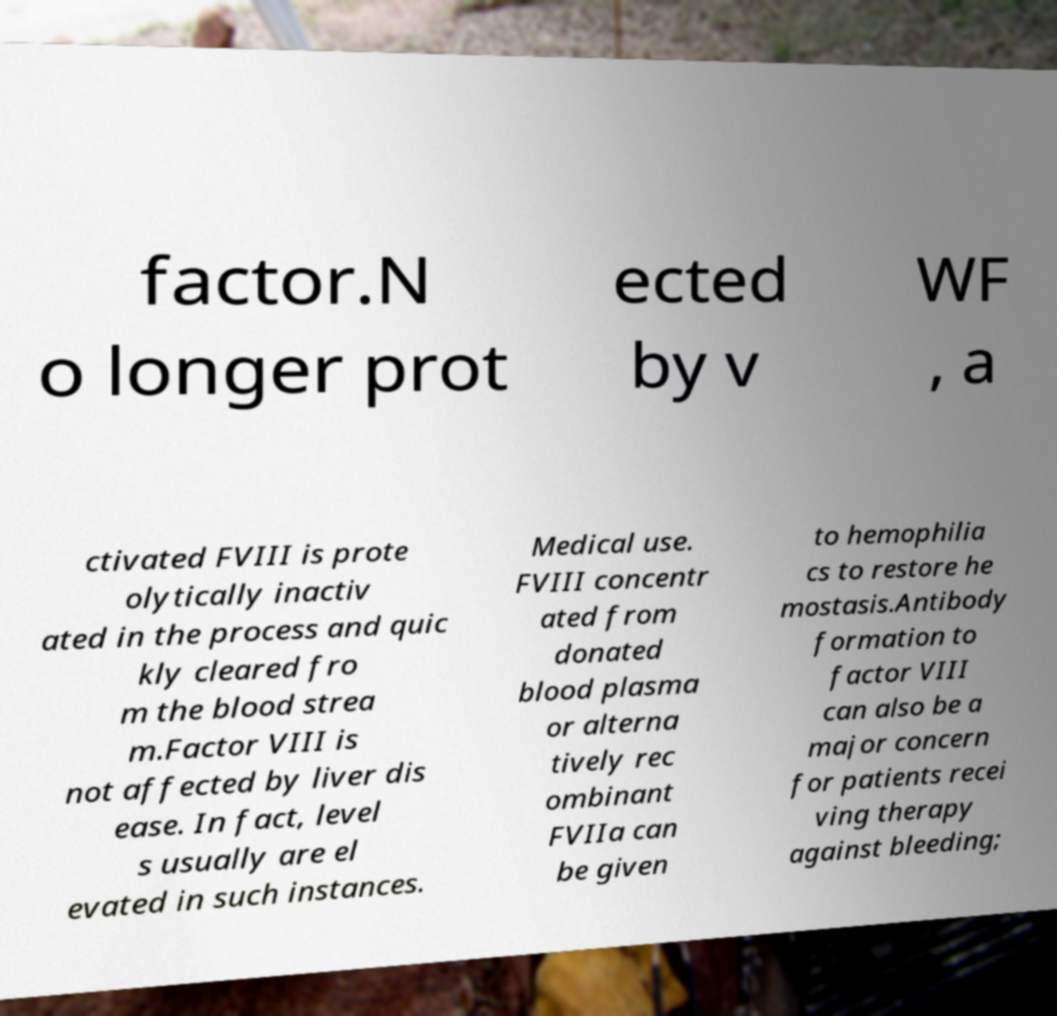Could you assist in decoding the text presented in this image and type it out clearly? factor.N o longer prot ected by v WF , a ctivated FVIII is prote olytically inactiv ated in the process and quic kly cleared fro m the blood strea m.Factor VIII is not affected by liver dis ease. In fact, level s usually are el evated in such instances. Medical use. FVIII concentr ated from donated blood plasma or alterna tively rec ombinant FVIIa can be given to hemophilia cs to restore he mostasis.Antibody formation to factor VIII can also be a major concern for patients recei ving therapy against bleeding; 